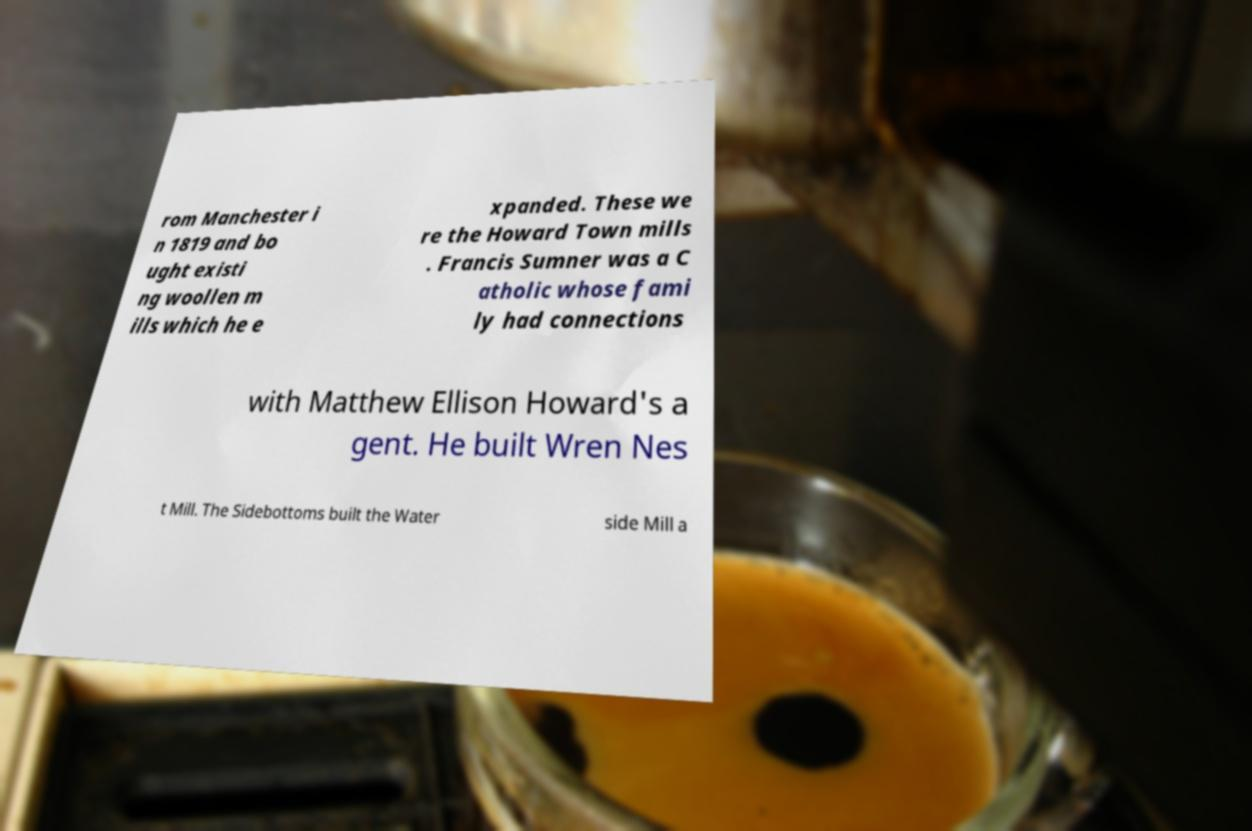Please identify and transcribe the text found in this image. rom Manchester i n 1819 and bo ught existi ng woollen m ills which he e xpanded. These we re the Howard Town mills . Francis Sumner was a C atholic whose fami ly had connections with Matthew Ellison Howard's a gent. He built Wren Nes t Mill. The Sidebottoms built the Water side Mill a 